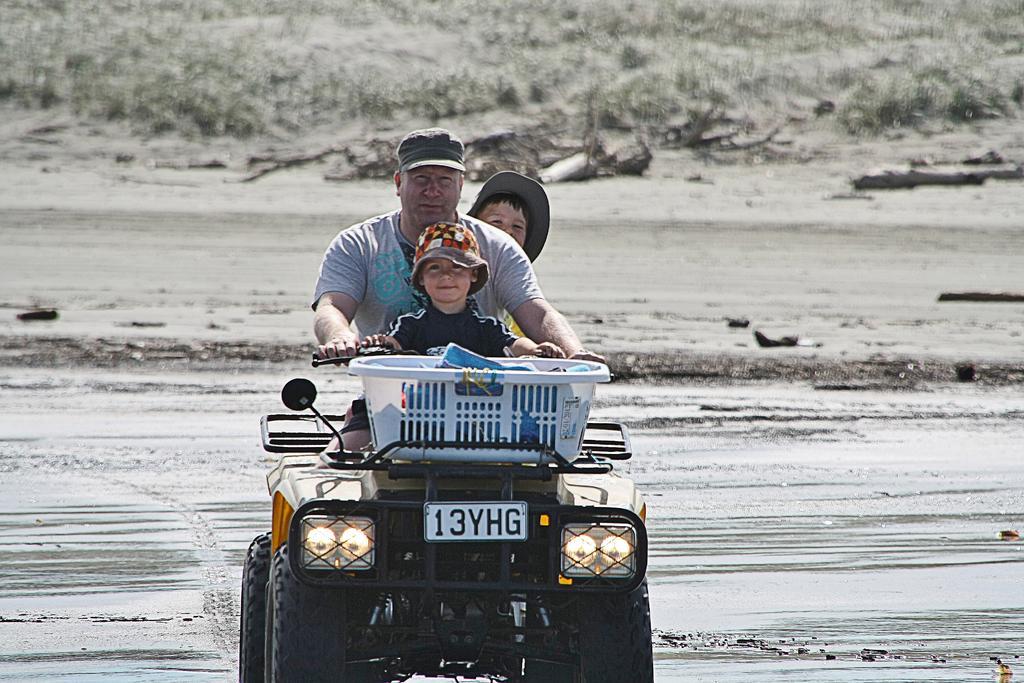How would you summarize this image in a sentence or two? In the picture we can find a man riding a cart and there is basket on the cart and few things in it. And they are two children sitting one at back and one on front. In the background we can find grass, mud, rocks. 